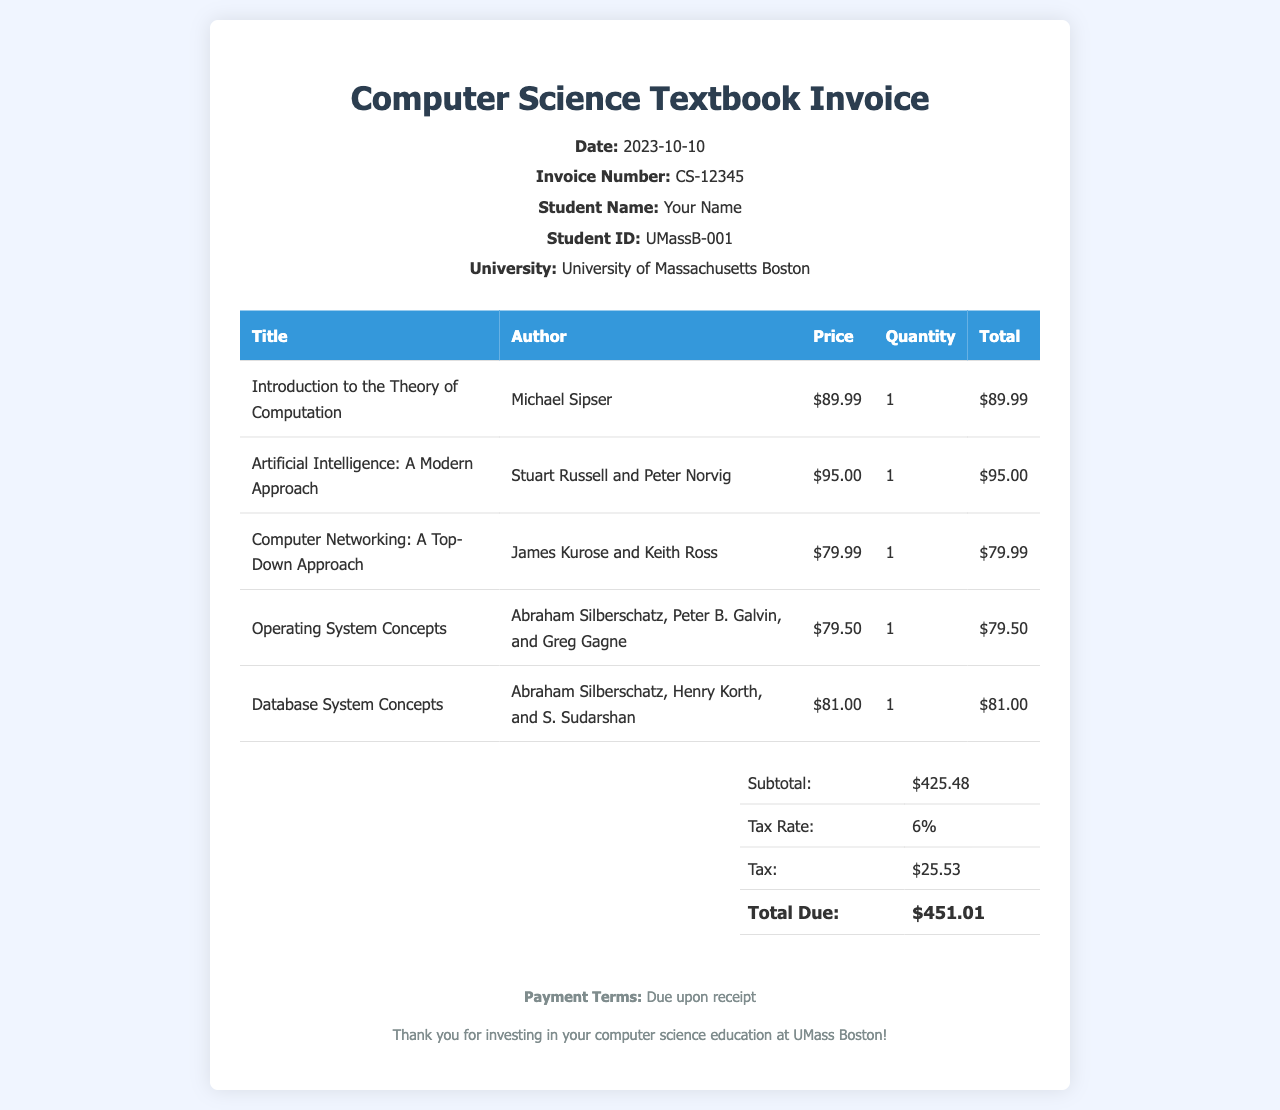what is the invoice number? The invoice number is located in the header of the document, under "Invoice Number."
Answer: CS-12345 who is the author of "Artificial Intelligence: A Modern Approach"? The author information is found in the table where books are listed.
Answer: Stuart Russell and Peter Norvig what is the price of "Database System Concepts"? The price can be found in the table next to the title of the book.
Answer: $81.00 how much is the tax amount? The tax amount can be calculated based on the subtotal and tax rate indicated in the total section.
Answer: $25.53 what is the total due? The total due is the final amount calculated in the total section of the invoice.
Answer: $451.01 what is the subtotal of the invoice? The subtotal is presented in the total section before taxes are included.
Answer: $425.48 how many textbooks are listed in the invoice? The number of textbooks can be counted from the rows in the items table excluding the header row.
Answer: 5 what is the date of the invoice? The date is stated directly in the header section of the invoice.
Answer: 2023-10-10 what are the payment terms? The payment terms are specified in the footer section of the invoice.
Answer: Due upon receipt 